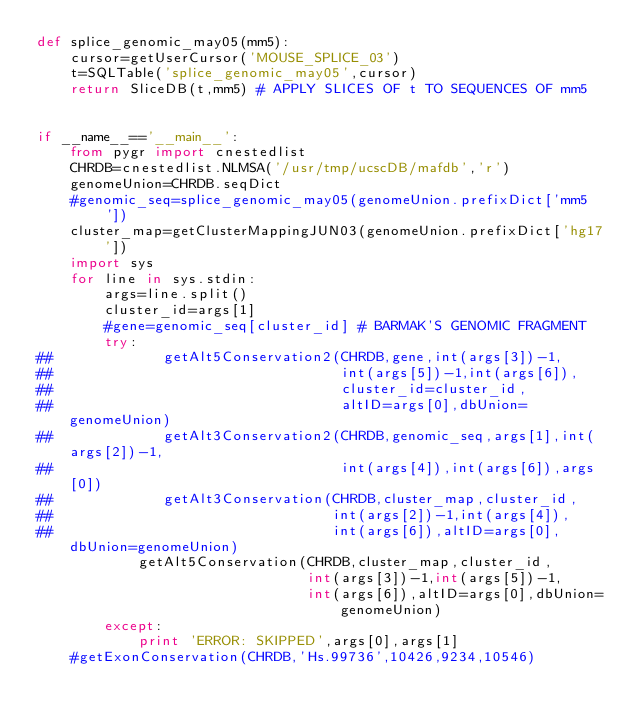Convert code to text. <code><loc_0><loc_0><loc_500><loc_500><_Python_>def splice_genomic_may05(mm5):
    cursor=getUserCursor('MOUSE_SPLICE_03')
    t=SQLTable('splice_genomic_may05',cursor)
    return SliceDB(t,mm5) # APPLY SLICES OF t TO SEQUENCES OF mm5


if __name__=='__main__':
    from pygr import cnestedlist
    CHRDB=cnestedlist.NLMSA('/usr/tmp/ucscDB/mafdb','r')
    genomeUnion=CHRDB.seqDict
    #genomic_seq=splice_genomic_may05(genomeUnion.prefixDict['mm5'])
    cluster_map=getClusterMappingJUN03(genomeUnion.prefixDict['hg17'])
    import sys
    for line in sys.stdin:
        args=line.split()
        cluster_id=args[1]
        #gene=genomic_seq[cluster_id] # BARMAK'S GENOMIC FRAGMENT
        try:
##             getAlt5Conservation2(CHRDB,gene,int(args[3])-1,
##                                  int(args[5])-1,int(args[6]),
##                                  cluster_id=cluster_id,
##                                  altID=args[0],dbUnion=genomeUnion)
##             getAlt3Conservation2(CHRDB,genomic_seq,args[1],int(args[2])-1,
##                                  int(args[4]),int(args[6]),args[0])
##             getAlt3Conservation(CHRDB,cluster_map,cluster_id,
##                                 int(args[2])-1,int(args[4]),
##                                 int(args[6]),altID=args[0],dbUnion=genomeUnion)
            getAlt5Conservation(CHRDB,cluster_map,cluster_id,
                                int(args[3])-1,int(args[5])-1,
                                int(args[6]),altID=args[0],dbUnion=genomeUnion)
        except:
            print 'ERROR: SKIPPED',args[0],args[1]
    #getExonConservation(CHRDB,'Hs.99736',10426,9234,10546)
</code> 